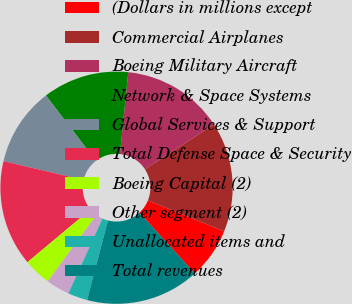Convert chart to OTSL. <chart><loc_0><loc_0><loc_500><loc_500><pie_chart><fcel>(Dollars in millions except<fcel>Commercial Airplanes<fcel>Boeing Military Aircraft<fcel>Network & Space Systems<fcel>Global Services & Support<fcel>Total Defense Space & Security<fcel>Boeing Capital (2)<fcel>Other segment (2)<fcel>Unallocated items and<fcel>Total revenues<nl><fcel>7.1%<fcel>15.3%<fcel>14.21%<fcel>12.02%<fcel>10.93%<fcel>14.75%<fcel>3.83%<fcel>3.28%<fcel>2.73%<fcel>15.85%<nl></chart> 